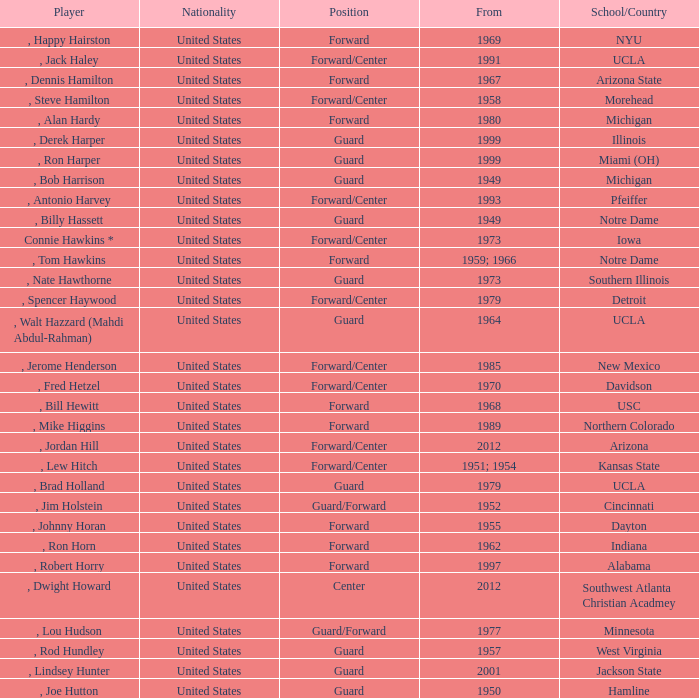Which player started in 2001? , Lindsey Hunter. 